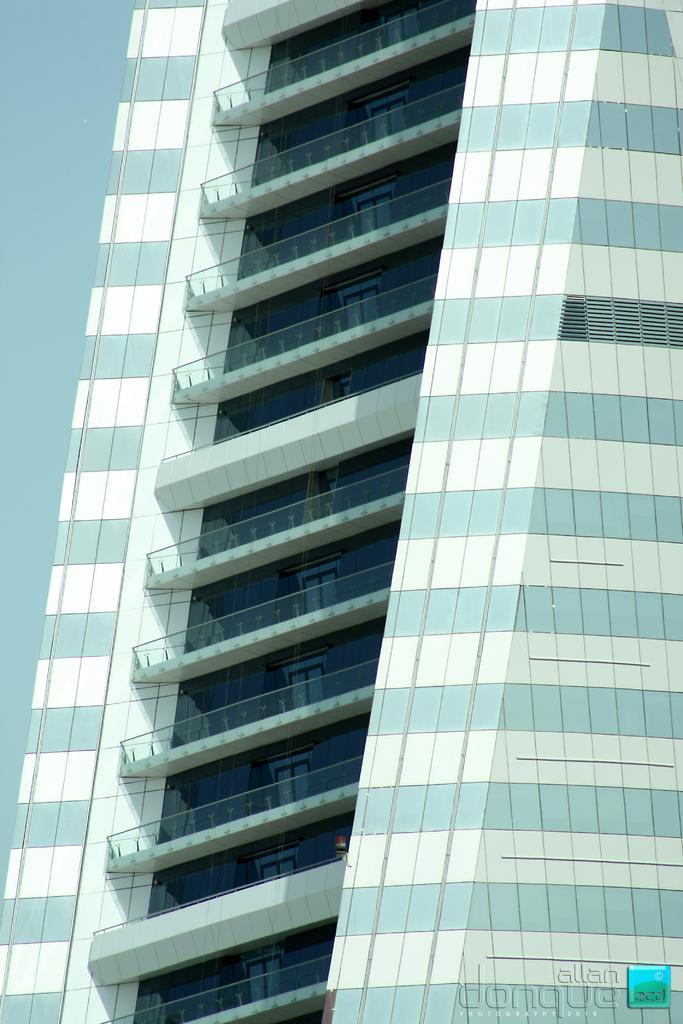In one or two sentences, can you explain what this image depicts? In this image in the front there is a building. 